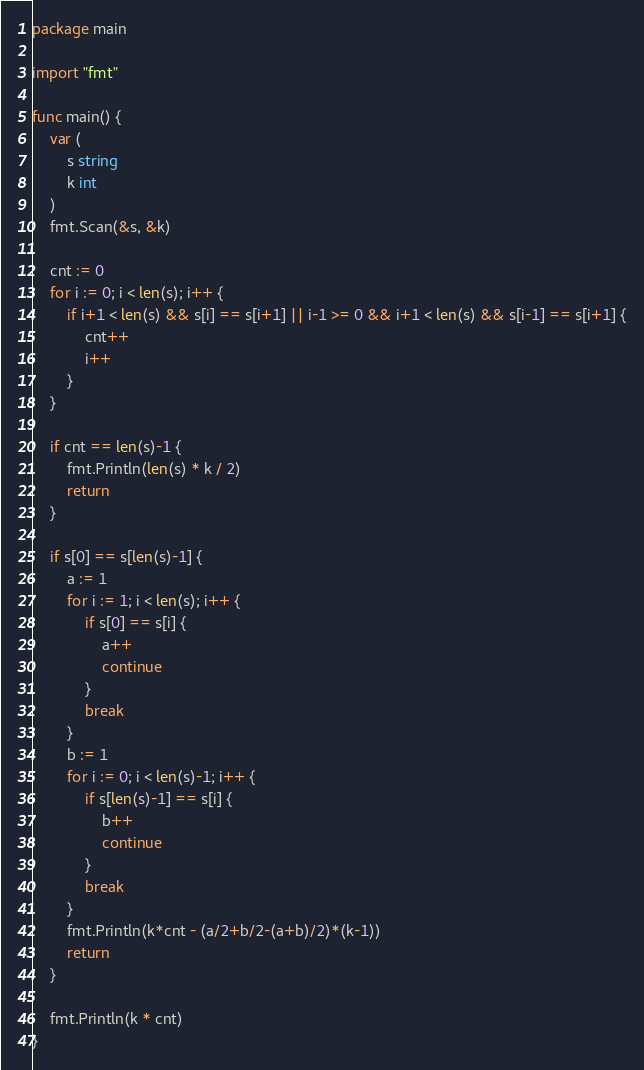<code> <loc_0><loc_0><loc_500><loc_500><_Go_>package main

import "fmt"

func main() {
	var (
		s string
		k int
	)
	fmt.Scan(&s, &k)

	cnt := 0
	for i := 0; i < len(s); i++ {
		if i+1 < len(s) && s[i] == s[i+1] || i-1 >= 0 && i+1 < len(s) && s[i-1] == s[i+1] {
			cnt++
			i++
		}
	}

	if cnt == len(s)-1 {
		fmt.Println(len(s) * k / 2)
		return
	}

	if s[0] == s[len(s)-1] {
		a := 1
		for i := 1; i < len(s); i++ {
			if s[0] == s[i] {
				a++
				continue
			}
			break
		}
		b := 1
		for i := 0; i < len(s)-1; i++ {
			if s[len(s)-1] == s[i] {
				b++
				continue
			}
			break
		}
		fmt.Println(k*cnt - (a/2+b/2-(a+b)/2)*(k-1))
		return
	}

	fmt.Println(k * cnt)
}
</code> 